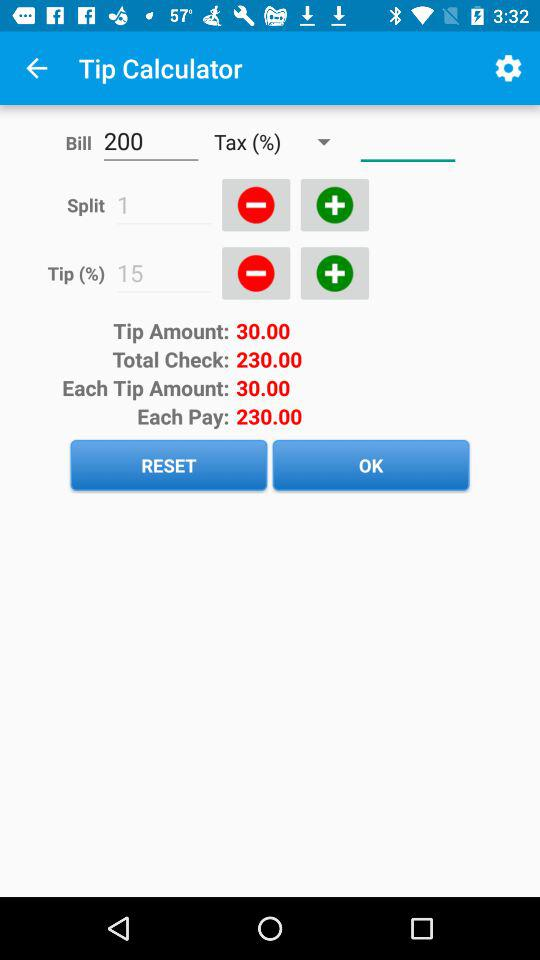What is the amount of each tip? The amount of each tip is 30.00. 